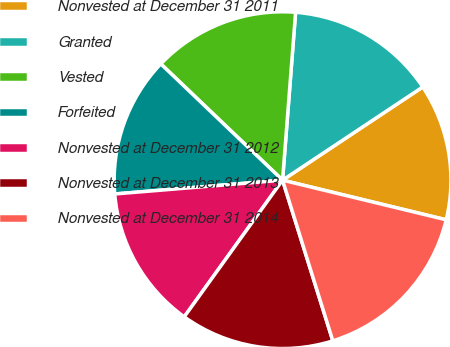Convert chart. <chart><loc_0><loc_0><loc_500><loc_500><pie_chart><fcel>Nonvested at December 31 2011<fcel>Granted<fcel>Vested<fcel>Forfeited<fcel>Nonvested at December 31 2012<fcel>Nonvested at December 31 2013<fcel>Nonvested at December 31 2014<nl><fcel>13.12%<fcel>14.43%<fcel>14.1%<fcel>13.44%<fcel>13.77%<fcel>14.75%<fcel>16.39%<nl></chart> 